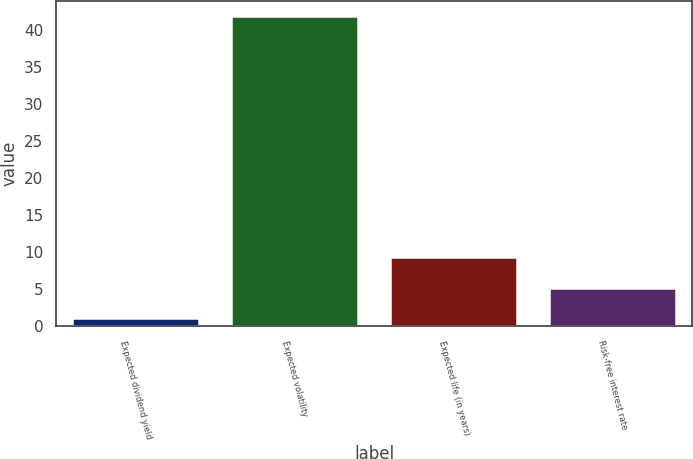<chart> <loc_0><loc_0><loc_500><loc_500><bar_chart><fcel>Expected dividend yield<fcel>Expected volatility<fcel>Expected life (in years)<fcel>Risk-free interest rate<nl><fcel>1.13<fcel>41.9<fcel>9.29<fcel>5.21<nl></chart> 